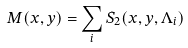Convert formula to latex. <formula><loc_0><loc_0><loc_500><loc_500>M ( x , y ) = \sum _ { i } S _ { 2 } ( x , y , \Lambda _ { i } )</formula> 